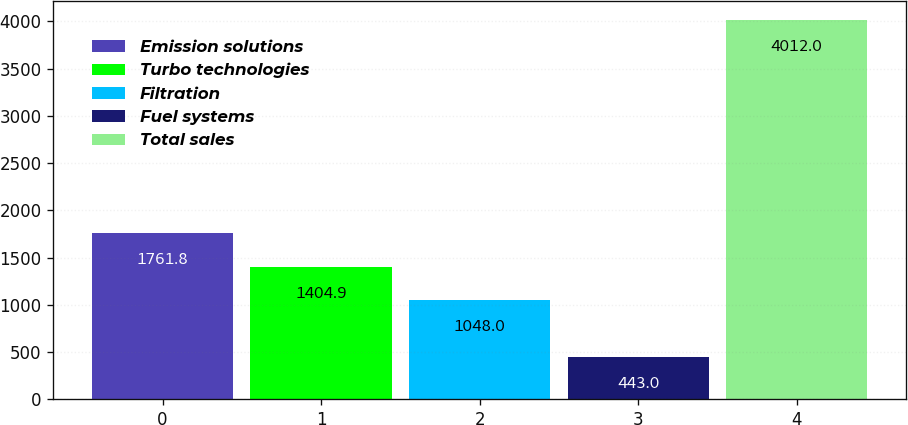<chart> <loc_0><loc_0><loc_500><loc_500><bar_chart><fcel>Emission solutions<fcel>Turbo technologies<fcel>Filtration<fcel>Fuel systems<fcel>Total sales<nl><fcel>1761.8<fcel>1404.9<fcel>1048<fcel>443<fcel>4012<nl></chart> 